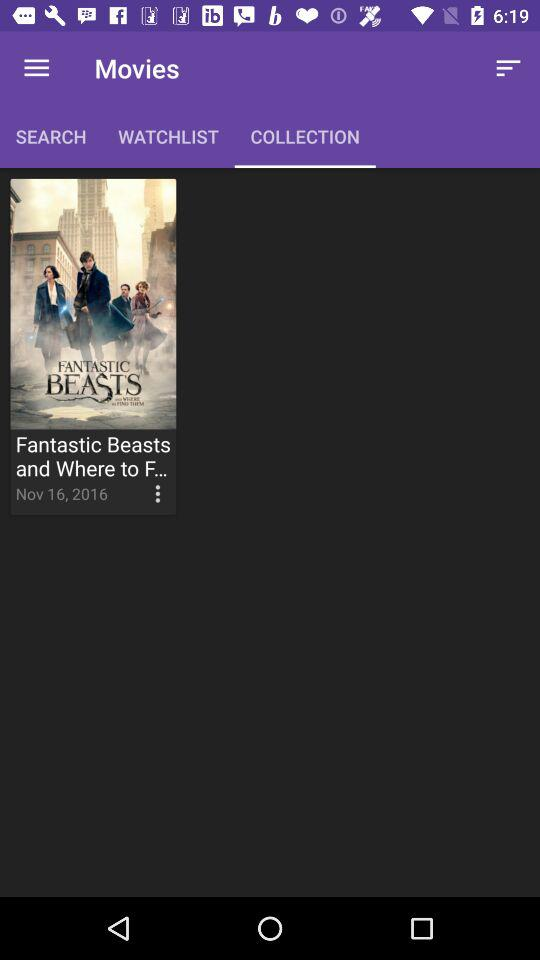What is the name of the movie? The name of the movie is "Fantastic Beasts and Where to F...". 